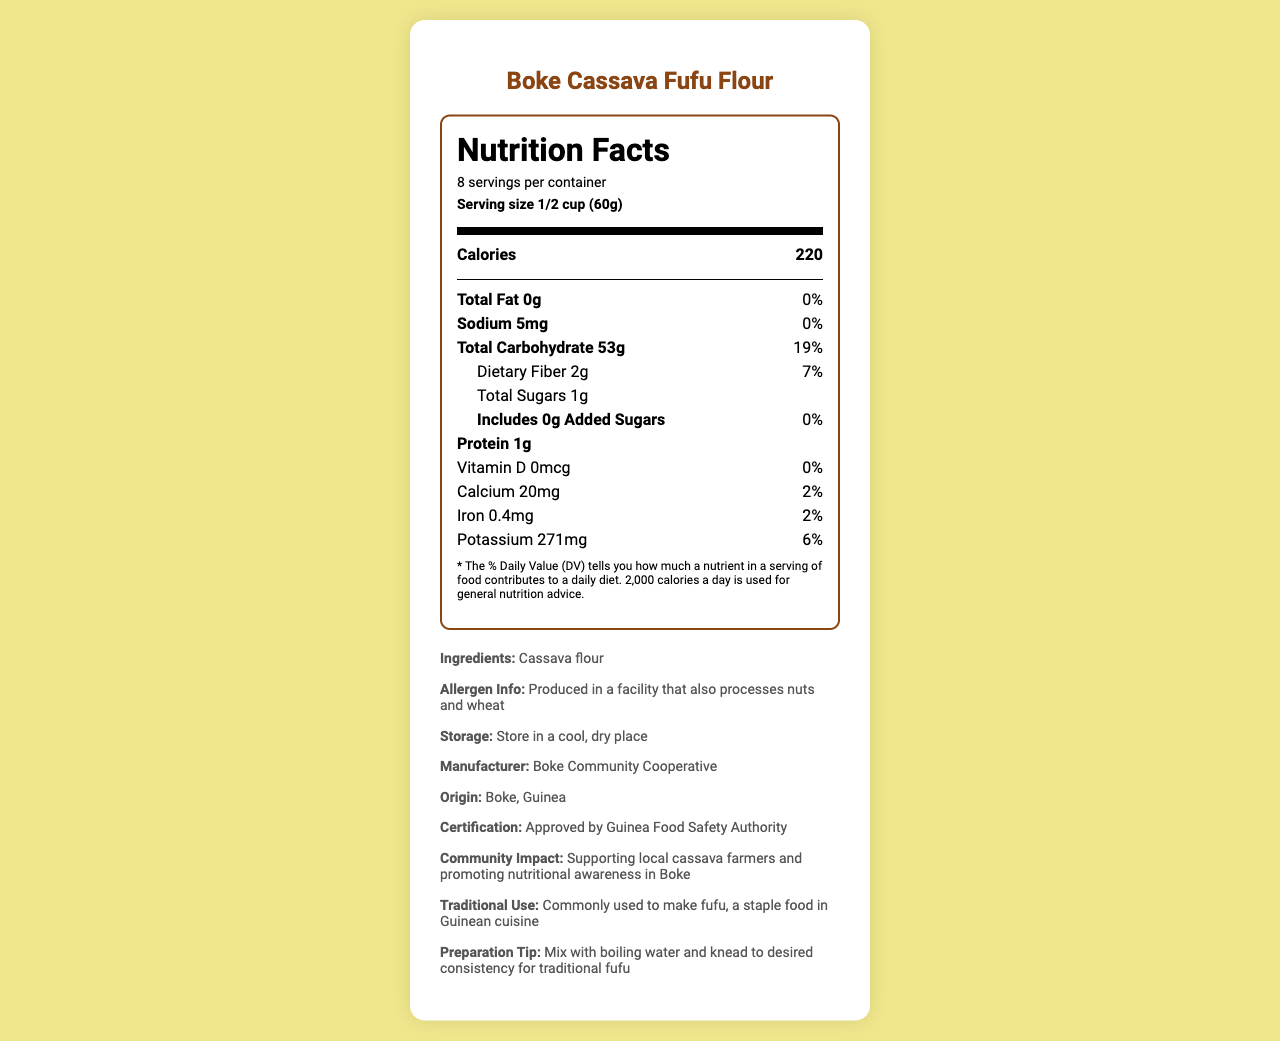what is the serving size for Boke Cassava Fufu Flour? The document clearly states that the serving size is 1/2 cup (60g).
Answer: 1/2 cup (60g) How many servings are there per container of Boke Cassava Fufu Flour? The document mentions that there are 8 servings per container.
Answer: 8 What is the total carbohydrate content per serving of Boke Cassava Fufu Flour? In the nutrition facts, it lists 53g as the total carbohydrate amount per serving.
Answer: 53g How much dietary fiber is in one serving? The document shows that there are 2g of dietary fiber per serving.
Answer: 2g What is the daily value percentage for dietary fiber in Boke Cassava Fufu Flour? The document indicates that the dietary fiber content contributes to 7% of the daily value.
Answer: 7% How many calories are there in one serving of Boke Cassava Fufu Flour? It is stated that one serving of the product contains 220 calories.
Answer: 220 What is the recommended storage condition for Boke Cassava Fufu Flour? The storage instructions specify to "Store in a cool, dry place".
Answer: Store in a cool, dry place Who is the manufacturer of Boke Cassava Fufu Flour? The document lists "Boke Community Cooperative" as the manufacturer.
Answer: Boke Community Cooperative What is the percentage of daily value for sodium in one serving? According to the nutrition facts, the sodium content has a daily value percentage of 0%.
Answer: 0% Does Boke Cassava Fufu Flour contain any added sugars? The nutrition facts label shows that added sugars amount is 0g and the daily value is 0%.
Answer: No Which nutrient has the highest amount in a serving of Boke Cassava Fufu Flour? A. Protein B. Total Fat C. Total Carbohydrate D. Sodium The total carbohydrate content is 53g, which is significantly higher than other nutrients listed.
Answer: C. Total Carbohydrate What is the main ingredient of Boke Cassava Fufu Flour? A. Wheat B. Rice C. Cassava Flour D. Nuts The ingredient list states that the main ingredient is cassava flour.
Answer: C. Cassava Flour Is Boke Cassava Fufu Flour suitable for individuals with nut allergies? Yes/No The allergen information indicates that it is produced in a facility that also processes nuts.
Answer: No Summarize the nutritional information provided for Boke Cassava Fufu Flour. This summary encapsulates all the key nutritional information for the product, along with storage and ingredient details.
Answer: The nutrition facts for Boke Cassava Fufu Flour show that one serving (1/2 cup or 60g) contains 220 calories, 0g total fat, 5mg sodium (0% daily value), 53g total carbohydrate (19% daily value), 2g dietary fiber (7% daily value), 1g total sugars with 0g added sugars, and 1g protein. It also provides minor amounts of vitamins and minerals, including 20mg calcium (2% daily value), 0.4mg iron (2% daily value), and 271mg potassium (6% daily value). The product is made from cassava flour and has potential allergen exposure to nuts and wheat. What is the production year of Boke Cassava Fufu Flour? The document does not provide any information regarding the production year of the product.
Answer: Not enough information 